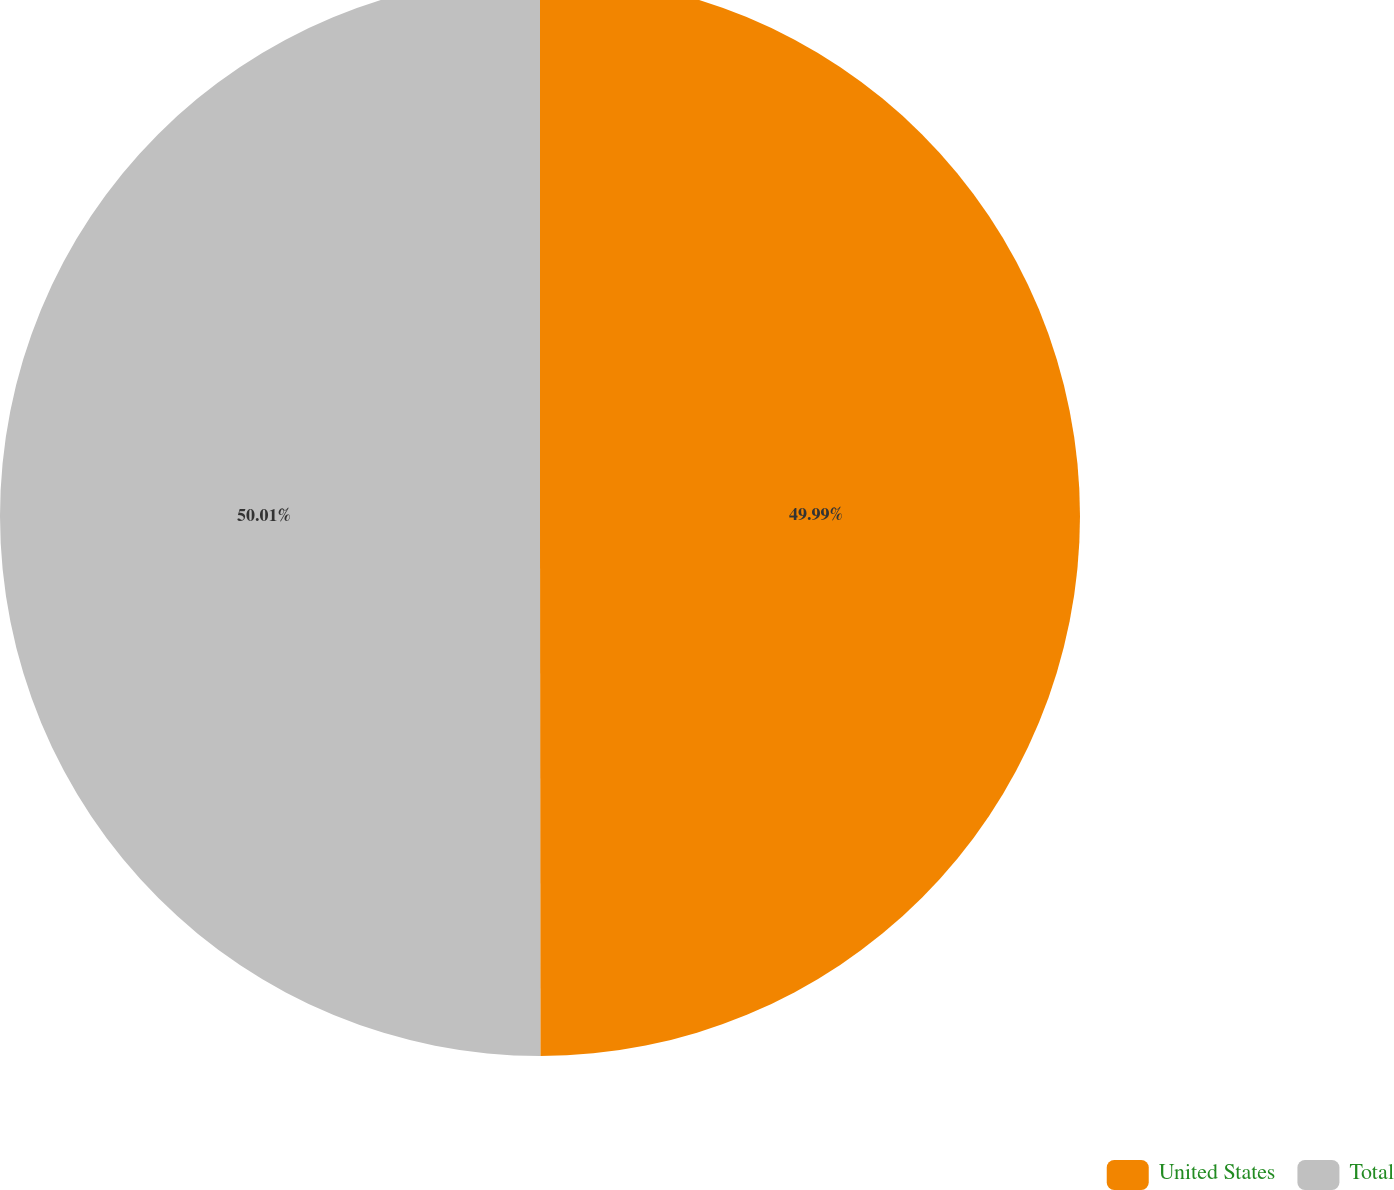<chart> <loc_0><loc_0><loc_500><loc_500><pie_chart><fcel>United States<fcel>Total<nl><fcel>49.99%<fcel>50.01%<nl></chart> 